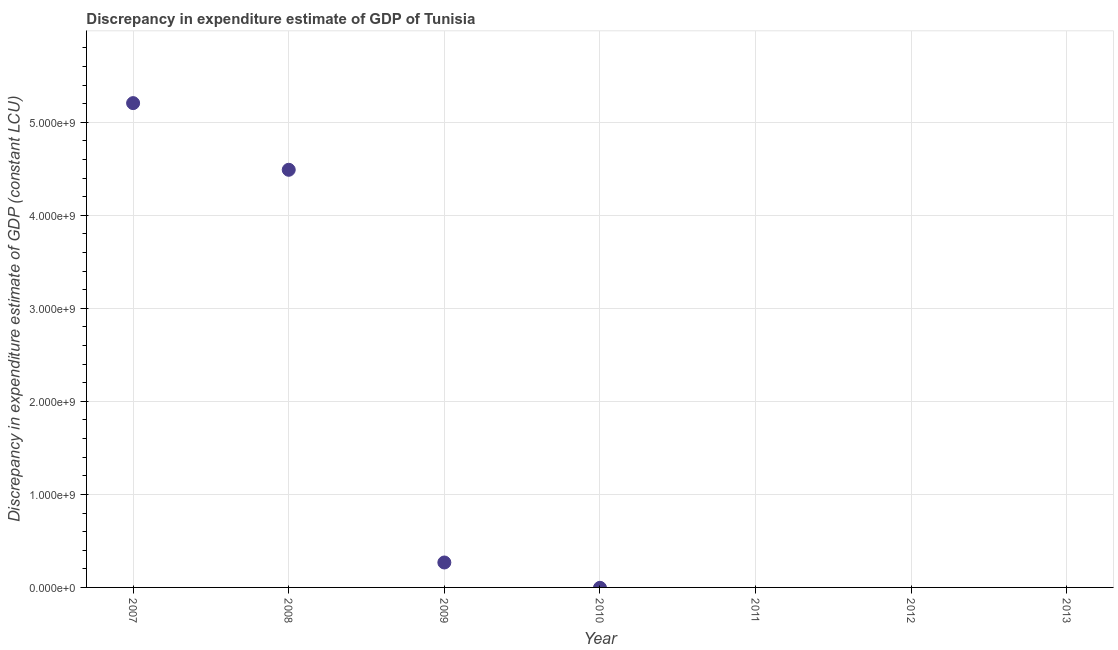Across all years, what is the maximum discrepancy in expenditure estimate of gdp?
Provide a short and direct response. 5.21e+09. What is the sum of the discrepancy in expenditure estimate of gdp?
Your answer should be very brief. 9.96e+09. What is the difference between the discrepancy in expenditure estimate of gdp in 2007 and 2008?
Give a very brief answer. 7.17e+08. What is the average discrepancy in expenditure estimate of gdp per year?
Give a very brief answer. 1.42e+09. In how many years, is the discrepancy in expenditure estimate of gdp greater than 5200000000 LCU?
Your answer should be very brief. 1. What is the difference between the highest and the second highest discrepancy in expenditure estimate of gdp?
Ensure brevity in your answer.  7.17e+08. What is the difference between the highest and the lowest discrepancy in expenditure estimate of gdp?
Your response must be concise. 5.21e+09. In how many years, is the discrepancy in expenditure estimate of gdp greater than the average discrepancy in expenditure estimate of gdp taken over all years?
Give a very brief answer. 2. Does the discrepancy in expenditure estimate of gdp monotonically increase over the years?
Provide a short and direct response. No. Does the graph contain any zero values?
Ensure brevity in your answer.  Yes. Does the graph contain grids?
Your answer should be very brief. Yes. What is the title of the graph?
Your answer should be compact. Discrepancy in expenditure estimate of GDP of Tunisia. What is the label or title of the X-axis?
Ensure brevity in your answer.  Year. What is the label or title of the Y-axis?
Make the answer very short. Discrepancy in expenditure estimate of GDP (constant LCU). What is the Discrepancy in expenditure estimate of GDP (constant LCU) in 2007?
Give a very brief answer. 5.21e+09. What is the Discrepancy in expenditure estimate of GDP (constant LCU) in 2008?
Make the answer very short. 4.49e+09. What is the Discrepancy in expenditure estimate of GDP (constant LCU) in 2009?
Offer a very short reply. 2.68e+08. What is the Discrepancy in expenditure estimate of GDP (constant LCU) in 2011?
Your answer should be compact. 0. What is the difference between the Discrepancy in expenditure estimate of GDP (constant LCU) in 2007 and 2008?
Offer a very short reply. 7.17e+08. What is the difference between the Discrepancy in expenditure estimate of GDP (constant LCU) in 2007 and 2009?
Your answer should be compact. 4.94e+09. What is the difference between the Discrepancy in expenditure estimate of GDP (constant LCU) in 2008 and 2009?
Your answer should be very brief. 4.22e+09. What is the ratio of the Discrepancy in expenditure estimate of GDP (constant LCU) in 2007 to that in 2008?
Your answer should be compact. 1.16. What is the ratio of the Discrepancy in expenditure estimate of GDP (constant LCU) in 2007 to that in 2009?
Ensure brevity in your answer.  19.42. What is the ratio of the Discrepancy in expenditure estimate of GDP (constant LCU) in 2008 to that in 2009?
Make the answer very short. 16.75. 